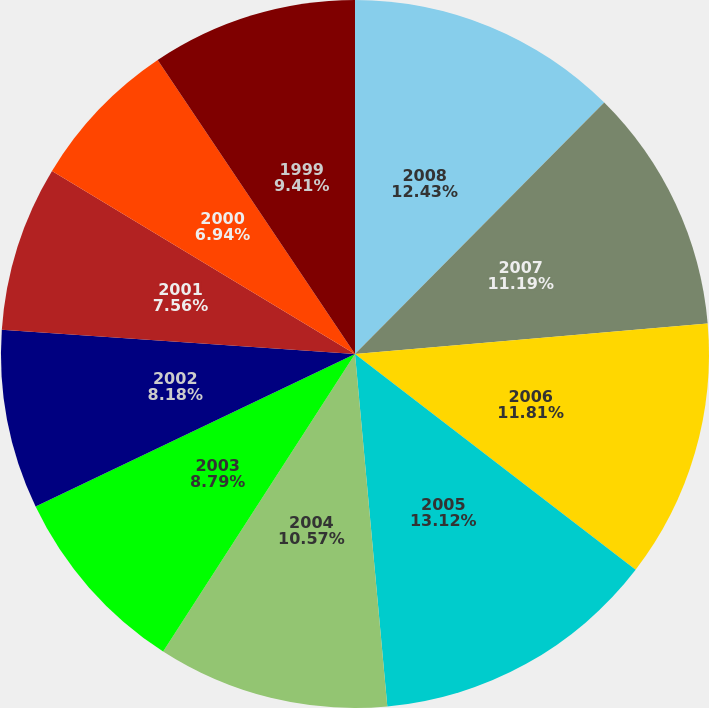Convert chart to OTSL. <chart><loc_0><loc_0><loc_500><loc_500><pie_chart><fcel>2008<fcel>2007<fcel>2006<fcel>2005<fcel>2004<fcel>2003<fcel>2002<fcel>2001<fcel>2000<fcel>1999<nl><fcel>12.43%<fcel>11.19%<fcel>11.81%<fcel>13.11%<fcel>10.57%<fcel>8.79%<fcel>8.18%<fcel>7.56%<fcel>6.94%<fcel>9.41%<nl></chart> 